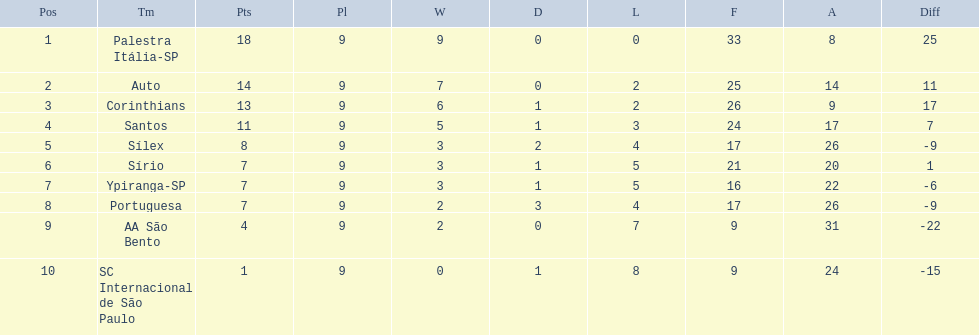What were all the teams that competed in 1926 brazilian football? Palestra Itália-SP, Auto, Corinthians, Santos, Sílex, Sírio, Ypiranga-SP, Portuguesa, AA São Bento, SC Internacional de São Paulo. Which of these had zero games lost? Palestra Itália-SP. 